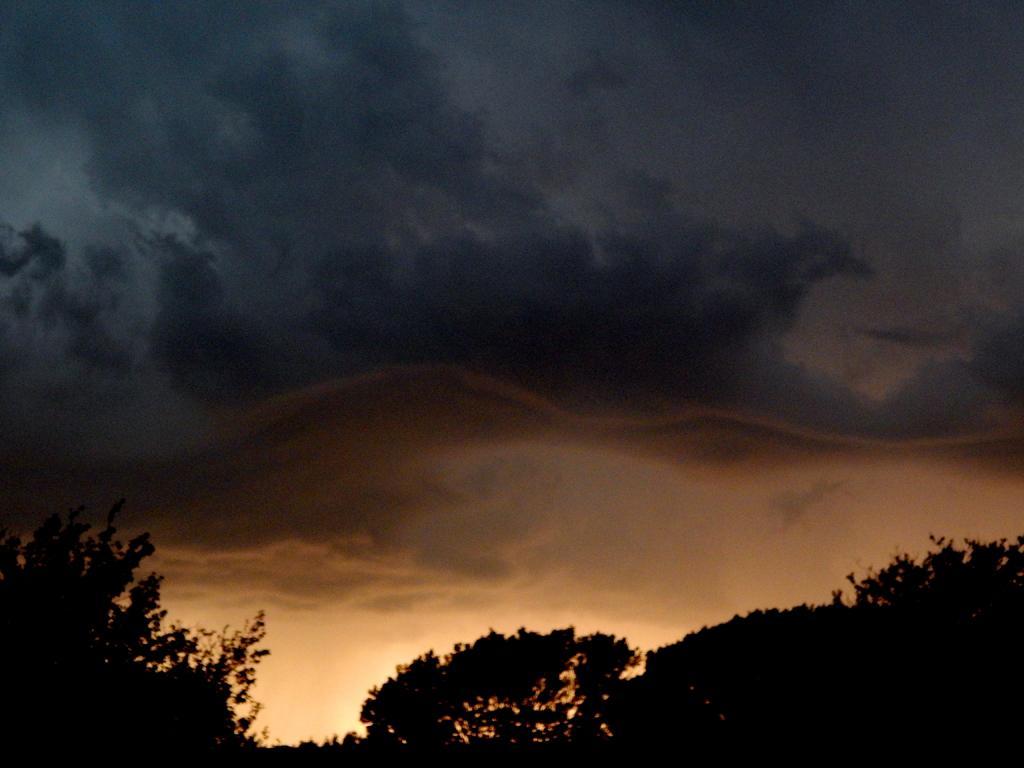Could you give a brief overview of what you see in this image? In this image we can see trees. The sky is covered with black color clouds. 